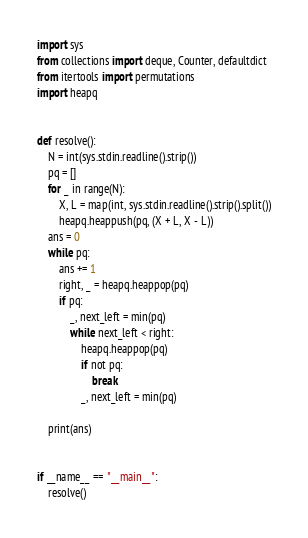<code> <loc_0><loc_0><loc_500><loc_500><_Python_>import sys
from collections import deque, Counter, defaultdict
from itertools import permutations
import heapq


def resolve():
    N = int(sys.stdin.readline().strip())
    pq = []
    for _ in range(N):
        X, L = map(int, sys.stdin.readline().strip().split())
        heapq.heappush(pq, (X + L, X - L))
    ans = 0
    while pq:
        ans += 1
        right, _ = heapq.heappop(pq)
        if pq:
            _, next_left = min(pq)
            while next_left < right:
                heapq.heappop(pq)
                if not pq:
                    break
                _, next_left = min(pq)

    print(ans)


if __name__ == "__main__":
    resolve()
</code> 